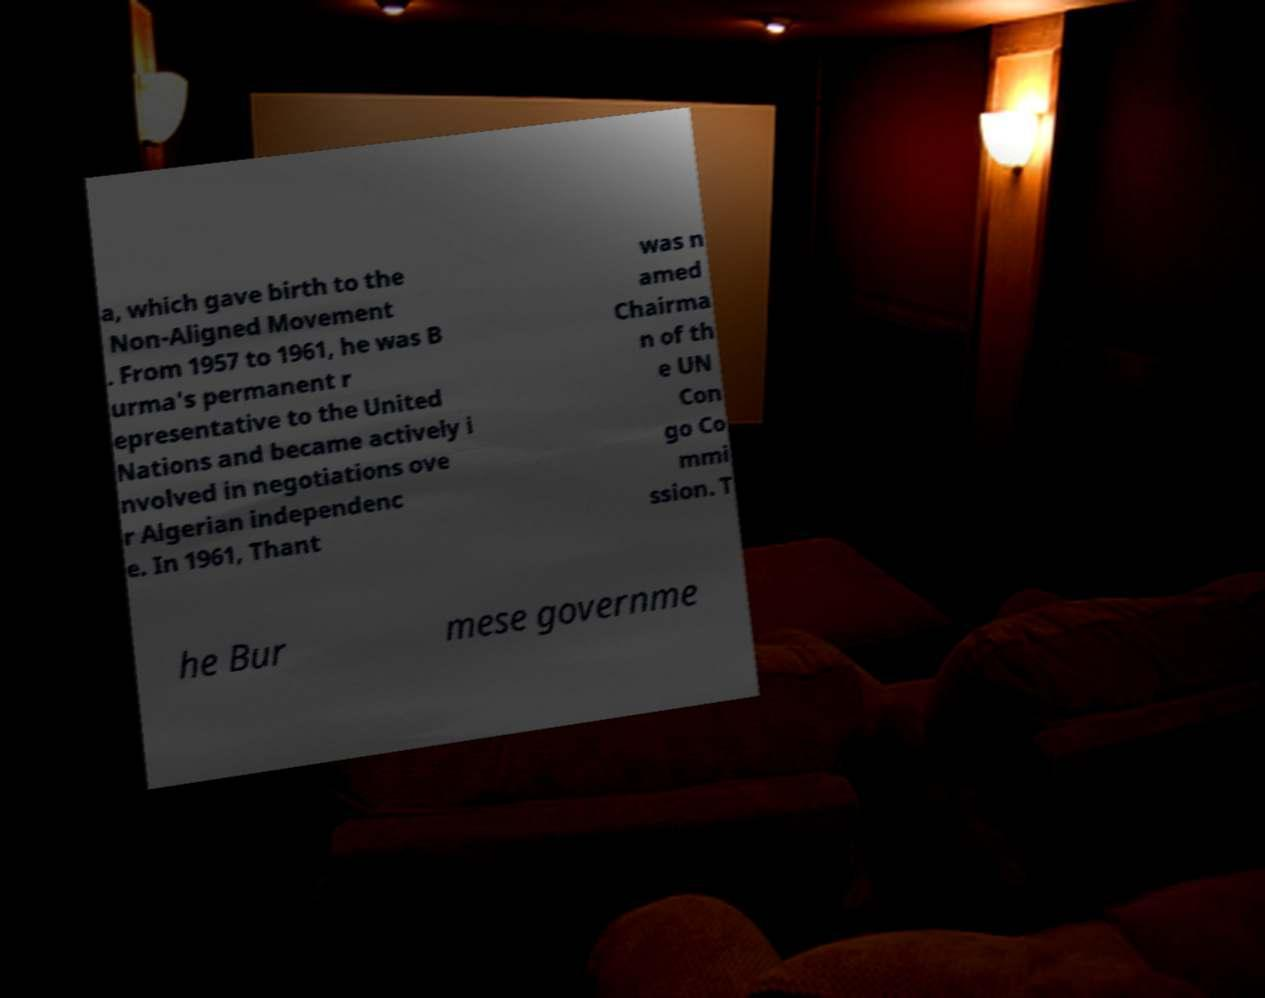Can you accurately transcribe the text from the provided image for me? a, which gave birth to the Non-Aligned Movement . From 1957 to 1961, he was B urma's permanent r epresentative to the United Nations and became actively i nvolved in negotiations ove r Algerian independenc e. In 1961, Thant was n amed Chairma n of th e UN Con go Co mmi ssion. T he Bur mese governme 